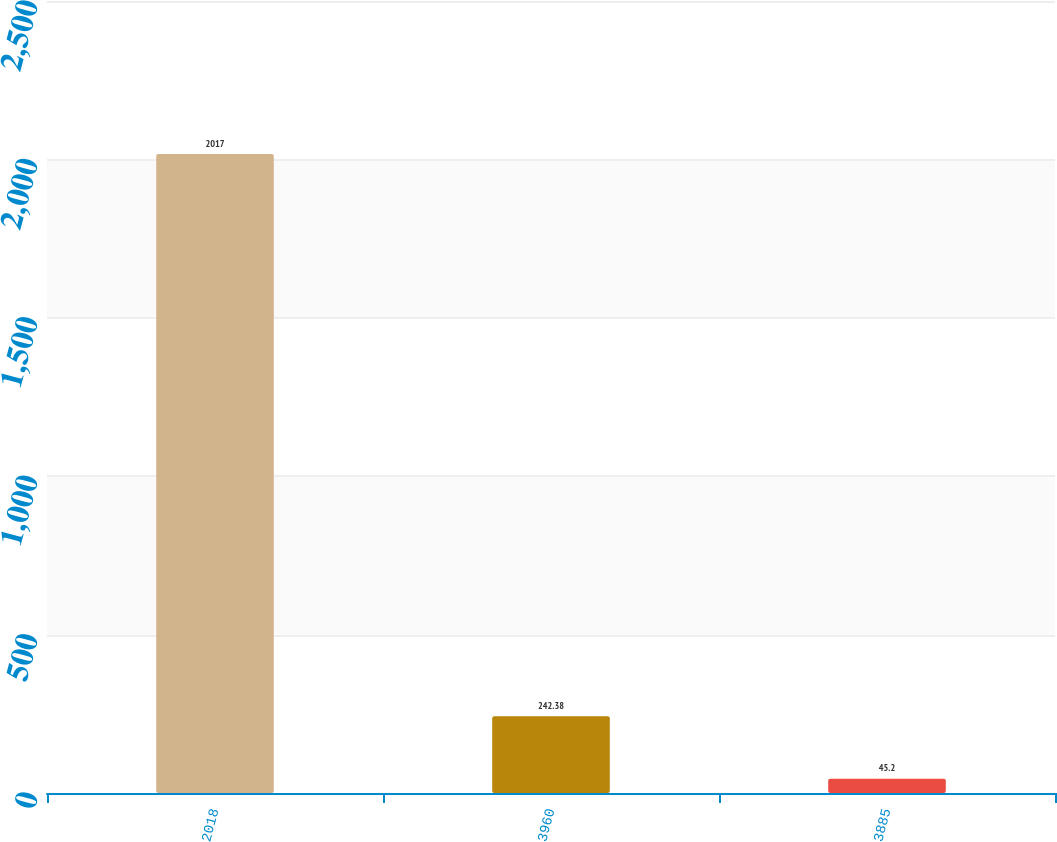Convert chart to OTSL. <chart><loc_0><loc_0><loc_500><loc_500><bar_chart><fcel>2018<fcel>3960<fcel>3885<nl><fcel>2017<fcel>242.38<fcel>45.2<nl></chart> 